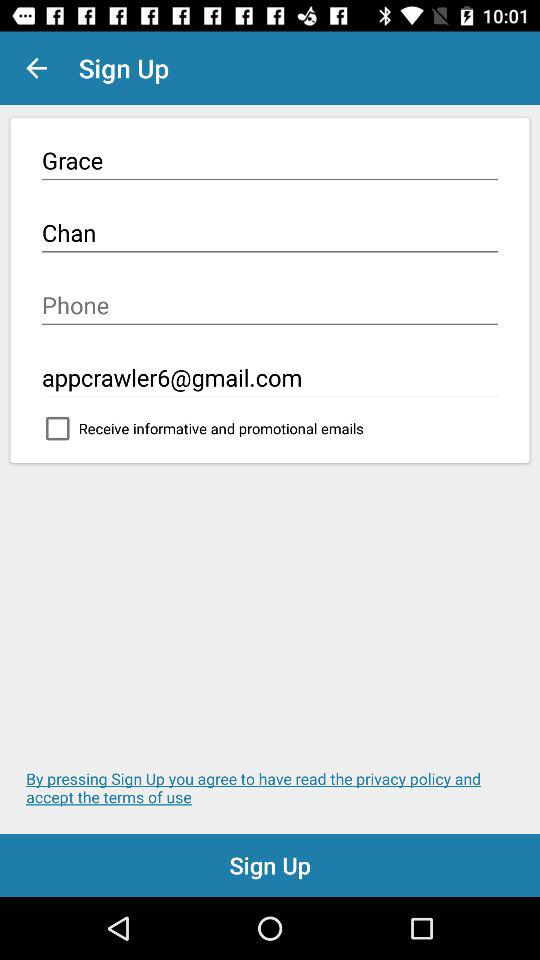What is Grace Chan's phone number?
When the provided information is insufficient, respond with <no answer>. <no answer> 